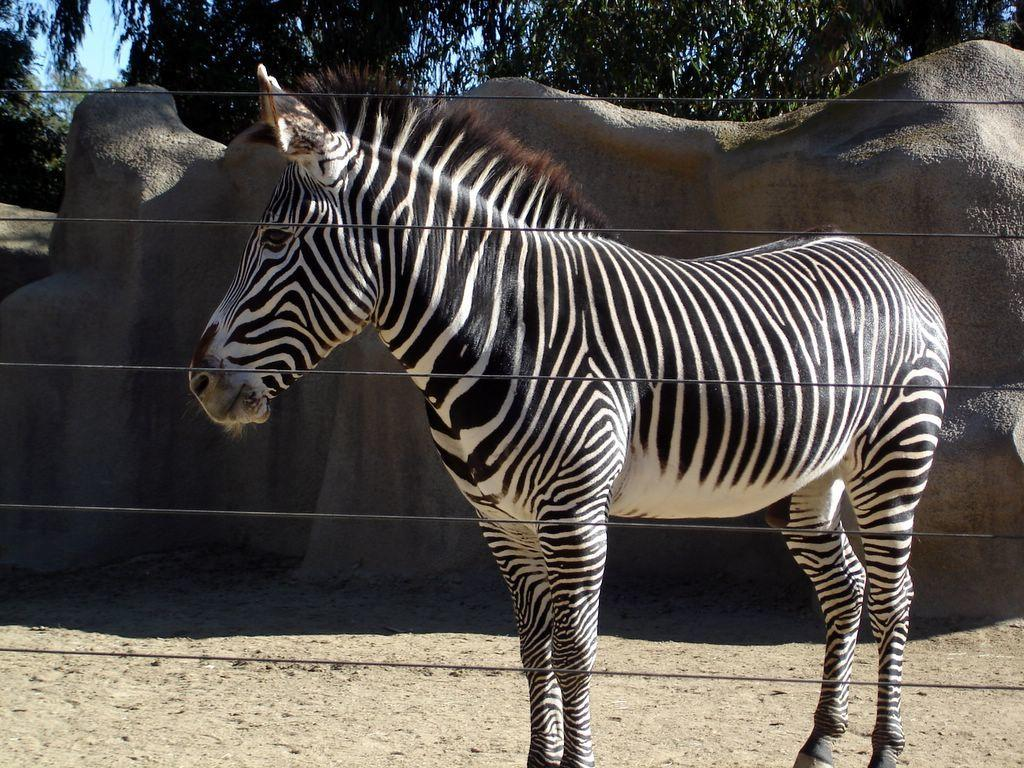What type of barrier is present in the image? There is fencing in the image. What animal is behind the fencing? There is a zebra behind the fencing. What type of terrain is visible behind the zebra? There are rocks visible behind the zebra. What type of vegetation is in the background of the image? There are trees in the background of the image. What type of ground is at the bottom of the image? There is sand at the bottom of the image. In which direction is the grain being transported in the image? There is no grain or transportation of any kind present in the image. What type of request is being made by the zebra in the image? There is no request being made by the zebra in the image; it is simply standing behind the fencing. 